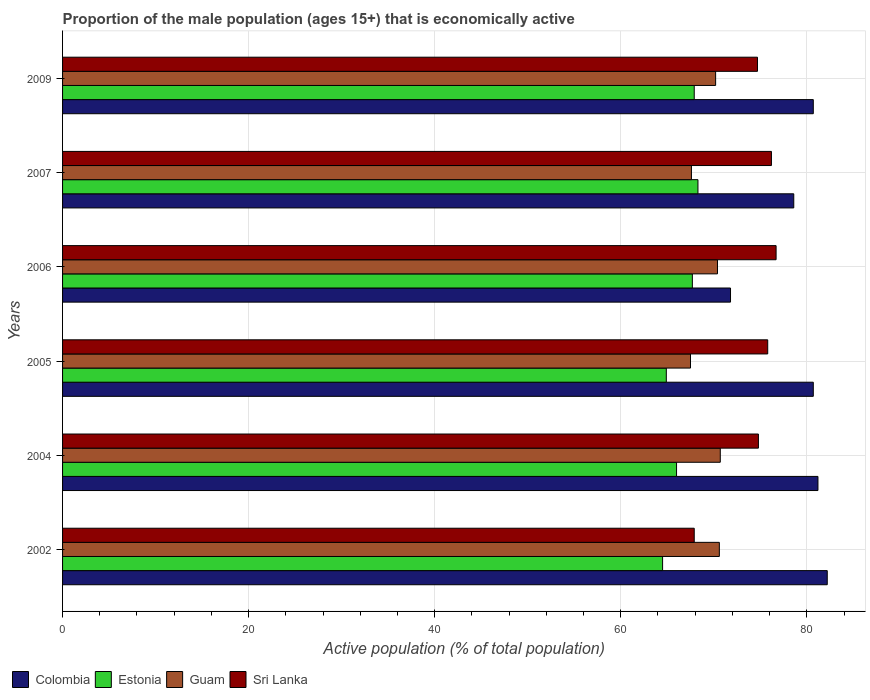Are the number of bars per tick equal to the number of legend labels?
Offer a terse response. Yes. Are the number of bars on each tick of the Y-axis equal?
Your response must be concise. Yes. What is the label of the 6th group of bars from the top?
Ensure brevity in your answer.  2002. What is the proportion of the male population that is economically active in Colombia in 2004?
Keep it short and to the point. 81.2. Across all years, what is the maximum proportion of the male population that is economically active in Colombia?
Keep it short and to the point. 82.2. Across all years, what is the minimum proportion of the male population that is economically active in Sri Lanka?
Your response must be concise. 67.9. In which year was the proportion of the male population that is economically active in Sri Lanka minimum?
Your answer should be compact. 2002. What is the total proportion of the male population that is economically active in Estonia in the graph?
Offer a terse response. 399.3. What is the difference between the proportion of the male population that is economically active in Guam in 2006 and that in 2009?
Provide a succinct answer. 0.2. What is the difference between the proportion of the male population that is economically active in Colombia in 2004 and the proportion of the male population that is economically active in Guam in 2009?
Your answer should be very brief. 11. What is the average proportion of the male population that is economically active in Colombia per year?
Make the answer very short. 79.2. In the year 2005, what is the difference between the proportion of the male population that is economically active in Sri Lanka and proportion of the male population that is economically active in Guam?
Keep it short and to the point. 8.3. What is the ratio of the proportion of the male population that is economically active in Guam in 2004 to that in 2007?
Your answer should be very brief. 1.05. Is the difference between the proportion of the male population that is economically active in Sri Lanka in 2002 and 2006 greater than the difference between the proportion of the male population that is economically active in Guam in 2002 and 2006?
Offer a terse response. No. What is the difference between the highest and the second highest proportion of the male population that is economically active in Guam?
Keep it short and to the point. 0.1. What is the difference between the highest and the lowest proportion of the male population that is economically active in Colombia?
Provide a short and direct response. 10.4. In how many years, is the proportion of the male population that is economically active in Guam greater than the average proportion of the male population that is economically active in Guam taken over all years?
Make the answer very short. 4. Is the sum of the proportion of the male population that is economically active in Estonia in 2005 and 2006 greater than the maximum proportion of the male population that is economically active in Colombia across all years?
Offer a very short reply. Yes. What does the 2nd bar from the top in 2006 represents?
Provide a succinct answer. Guam. What does the 3rd bar from the bottom in 2005 represents?
Your response must be concise. Guam. Are all the bars in the graph horizontal?
Make the answer very short. Yes. What is the difference between two consecutive major ticks on the X-axis?
Your response must be concise. 20. Does the graph contain grids?
Offer a terse response. Yes. Where does the legend appear in the graph?
Offer a terse response. Bottom left. How many legend labels are there?
Give a very brief answer. 4. What is the title of the graph?
Give a very brief answer. Proportion of the male population (ages 15+) that is economically active. Does "Portugal" appear as one of the legend labels in the graph?
Your answer should be compact. No. What is the label or title of the X-axis?
Make the answer very short. Active population (% of total population). What is the Active population (% of total population) of Colombia in 2002?
Keep it short and to the point. 82.2. What is the Active population (% of total population) of Estonia in 2002?
Your answer should be very brief. 64.5. What is the Active population (% of total population) in Guam in 2002?
Provide a short and direct response. 70.6. What is the Active population (% of total population) of Sri Lanka in 2002?
Offer a terse response. 67.9. What is the Active population (% of total population) in Colombia in 2004?
Ensure brevity in your answer.  81.2. What is the Active population (% of total population) of Estonia in 2004?
Your response must be concise. 66. What is the Active population (% of total population) in Guam in 2004?
Your answer should be compact. 70.7. What is the Active population (% of total population) of Sri Lanka in 2004?
Give a very brief answer. 74.8. What is the Active population (% of total population) in Colombia in 2005?
Make the answer very short. 80.7. What is the Active population (% of total population) of Estonia in 2005?
Ensure brevity in your answer.  64.9. What is the Active population (% of total population) of Guam in 2005?
Provide a succinct answer. 67.5. What is the Active population (% of total population) of Sri Lanka in 2005?
Ensure brevity in your answer.  75.8. What is the Active population (% of total population) in Colombia in 2006?
Ensure brevity in your answer.  71.8. What is the Active population (% of total population) of Estonia in 2006?
Give a very brief answer. 67.7. What is the Active population (% of total population) of Guam in 2006?
Your answer should be very brief. 70.4. What is the Active population (% of total population) in Sri Lanka in 2006?
Your answer should be very brief. 76.7. What is the Active population (% of total population) of Colombia in 2007?
Your answer should be very brief. 78.6. What is the Active population (% of total population) in Estonia in 2007?
Keep it short and to the point. 68.3. What is the Active population (% of total population) of Guam in 2007?
Make the answer very short. 67.6. What is the Active population (% of total population) of Sri Lanka in 2007?
Provide a short and direct response. 76.2. What is the Active population (% of total population) in Colombia in 2009?
Offer a very short reply. 80.7. What is the Active population (% of total population) of Estonia in 2009?
Ensure brevity in your answer.  67.9. What is the Active population (% of total population) of Guam in 2009?
Keep it short and to the point. 70.2. What is the Active population (% of total population) of Sri Lanka in 2009?
Your answer should be very brief. 74.7. Across all years, what is the maximum Active population (% of total population) of Colombia?
Your response must be concise. 82.2. Across all years, what is the maximum Active population (% of total population) of Estonia?
Offer a very short reply. 68.3. Across all years, what is the maximum Active population (% of total population) in Guam?
Provide a short and direct response. 70.7. Across all years, what is the maximum Active population (% of total population) of Sri Lanka?
Offer a terse response. 76.7. Across all years, what is the minimum Active population (% of total population) of Colombia?
Keep it short and to the point. 71.8. Across all years, what is the minimum Active population (% of total population) of Estonia?
Your answer should be compact. 64.5. Across all years, what is the minimum Active population (% of total population) of Guam?
Ensure brevity in your answer.  67.5. Across all years, what is the minimum Active population (% of total population) of Sri Lanka?
Your answer should be compact. 67.9. What is the total Active population (% of total population) in Colombia in the graph?
Provide a succinct answer. 475.2. What is the total Active population (% of total population) in Estonia in the graph?
Your answer should be compact. 399.3. What is the total Active population (% of total population) of Guam in the graph?
Provide a succinct answer. 417. What is the total Active population (% of total population) in Sri Lanka in the graph?
Offer a terse response. 446.1. What is the difference between the Active population (% of total population) of Guam in 2002 and that in 2004?
Your answer should be compact. -0.1. What is the difference between the Active population (% of total population) of Sri Lanka in 2002 and that in 2004?
Provide a succinct answer. -6.9. What is the difference between the Active population (% of total population) in Colombia in 2002 and that in 2005?
Your response must be concise. 1.5. What is the difference between the Active population (% of total population) in Estonia in 2002 and that in 2005?
Ensure brevity in your answer.  -0.4. What is the difference between the Active population (% of total population) of Colombia in 2002 and that in 2006?
Give a very brief answer. 10.4. What is the difference between the Active population (% of total population) of Estonia in 2002 and that in 2006?
Make the answer very short. -3.2. What is the difference between the Active population (% of total population) of Guam in 2002 and that in 2006?
Your answer should be very brief. 0.2. What is the difference between the Active population (% of total population) in Sri Lanka in 2002 and that in 2006?
Your answer should be very brief. -8.8. What is the difference between the Active population (% of total population) of Colombia in 2002 and that in 2007?
Provide a succinct answer. 3.6. What is the difference between the Active population (% of total population) in Guam in 2002 and that in 2007?
Ensure brevity in your answer.  3. What is the difference between the Active population (% of total population) in Sri Lanka in 2002 and that in 2007?
Your answer should be compact. -8.3. What is the difference between the Active population (% of total population) of Colombia in 2002 and that in 2009?
Keep it short and to the point. 1.5. What is the difference between the Active population (% of total population) in Guam in 2004 and that in 2005?
Ensure brevity in your answer.  3.2. What is the difference between the Active population (% of total population) in Sri Lanka in 2004 and that in 2005?
Provide a succinct answer. -1. What is the difference between the Active population (% of total population) of Colombia in 2004 and that in 2006?
Provide a succinct answer. 9.4. What is the difference between the Active population (% of total population) of Guam in 2004 and that in 2006?
Make the answer very short. 0.3. What is the difference between the Active population (% of total population) in Sri Lanka in 2004 and that in 2006?
Give a very brief answer. -1.9. What is the difference between the Active population (% of total population) in Colombia in 2004 and that in 2007?
Make the answer very short. 2.6. What is the difference between the Active population (% of total population) in Estonia in 2004 and that in 2007?
Your response must be concise. -2.3. What is the difference between the Active population (% of total population) of Guam in 2004 and that in 2007?
Your response must be concise. 3.1. What is the difference between the Active population (% of total population) in Colombia in 2004 and that in 2009?
Make the answer very short. 0.5. What is the difference between the Active population (% of total population) of Guam in 2004 and that in 2009?
Your response must be concise. 0.5. What is the difference between the Active population (% of total population) in Colombia in 2005 and that in 2006?
Make the answer very short. 8.9. What is the difference between the Active population (% of total population) of Estonia in 2005 and that in 2006?
Offer a terse response. -2.8. What is the difference between the Active population (% of total population) of Sri Lanka in 2005 and that in 2006?
Give a very brief answer. -0.9. What is the difference between the Active population (% of total population) in Colombia in 2005 and that in 2007?
Offer a very short reply. 2.1. What is the difference between the Active population (% of total population) in Sri Lanka in 2005 and that in 2009?
Provide a short and direct response. 1.1. What is the difference between the Active population (% of total population) of Colombia in 2006 and that in 2009?
Offer a terse response. -8.9. What is the difference between the Active population (% of total population) in Guam in 2006 and that in 2009?
Your response must be concise. 0.2. What is the difference between the Active population (% of total population) in Sri Lanka in 2006 and that in 2009?
Your response must be concise. 2. What is the difference between the Active population (% of total population) of Colombia in 2007 and that in 2009?
Make the answer very short. -2.1. What is the difference between the Active population (% of total population) of Colombia in 2002 and the Active population (% of total population) of Guam in 2004?
Provide a succinct answer. 11.5. What is the difference between the Active population (% of total population) in Colombia in 2002 and the Active population (% of total population) in Sri Lanka in 2004?
Give a very brief answer. 7.4. What is the difference between the Active population (% of total population) in Estonia in 2002 and the Active population (% of total population) in Guam in 2004?
Your answer should be very brief. -6.2. What is the difference between the Active population (% of total population) of Estonia in 2002 and the Active population (% of total population) of Sri Lanka in 2004?
Offer a very short reply. -10.3. What is the difference between the Active population (% of total population) of Guam in 2002 and the Active population (% of total population) of Sri Lanka in 2004?
Offer a very short reply. -4.2. What is the difference between the Active population (% of total population) of Estonia in 2002 and the Active population (% of total population) of Guam in 2005?
Offer a terse response. -3. What is the difference between the Active population (% of total population) of Guam in 2002 and the Active population (% of total population) of Sri Lanka in 2005?
Offer a very short reply. -5.2. What is the difference between the Active population (% of total population) in Colombia in 2002 and the Active population (% of total population) in Guam in 2006?
Your response must be concise. 11.8. What is the difference between the Active population (% of total population) of Estonia in 2002 and the Active population (% of total population) of Guam in 2006?
Offer a very short reply. -5.9. What is the difference between the Active population (% of total population) of Guam in 2002 and the Active population (% of total population) of Sri Lanka in 2006?
Your answer should be very brief. -6.1. What is the difference between the Active population (% of total population) in Colombia in 2002 and the Active population (% of total population) in Estonia in 2007?
Offer a very short reply. 13.9. What is the difference between the Active population (% of total population) in Colombia in 2002 and the Active population (% of total population) in Sri Lanka in 2007?
Keep it short and to the point. 6. What is the difference between the Active population (% of total population) of Estonia in 2002 and the Active population (% of total population) of Sri Lanka in 2007?
Give a very brief answer. -11.7. What is the difference between the Active population (% of total population) of Colombia in 2002 and the Active population (% of total population) of Estonia in 2009?
Your answer should be compact. 14.3. What is the difference between the Active population (% of total population) in Colombia in 2002 and the Active population (% of total population) in Guam in 2009?
Provide a succinct answer. 12. What is the difference between the Active population (% of total population) in Colombia in 2002 and the Active population (% of total population) in Sri Lanka in 2009?
Ensure brevity in your answer.  7.5. What is the difference between the Active population (% of total population) of Guam in 2002 and the Active population (% of total population) of Sri Lanka in 2009?
Your answer should be compact. -4.1. What is the difference between the Active population (% of total population) of Colombia in 2004 and the Active population (% of total population) of Guam in 2005?
Offer a very short reply. 13.7. What is the difference between the Active population (% of total population) of Estonia in 2004 and the Active population (% of total population) of Guam in 2005?
Make the answer very short. -1.5. What is the difference between the Active population (% of total population) of Colombia in 2004 and the Active population (% of total population) of Guam in 2006?
Your answer should be very brief. 10.8. What is the difference between the Active population (% of total population) in Estonia in 2004 and the Active population (% of total population) in Guam in 2006?
Offer a very short reply. -4.4. What is the difference between the Active population (% of total population) in Guam in 2004 and the Active population (% of total population) in Sri Lanka in 2006?
Your response must be concise. -6. What is the difference between the Active population (% of total population) in Colombia in 2004 and the Active population (% of total population) in Sri Lanka in 2007?
Offer a very short reply. 5. What is the difference between the Active population (% of total population) in Estonia in 2004 and the Active population (% of total population) in Sri Lanka in 2007?
Offer a very short reply. -10.2. What is the difference between the Active population (% of total population) of Colombia in 2004 and the Active population (% of total population) of Guam in 2009?
Your answer should be very brief. 11. What is the difference between the Active population (% of total population) in Estonia in 2004 and the Active population (% of total population) in Sri Lanka in 2009?
Provide a short and direct response. -8.7. What is the difference between the Active population (% of total population) in Colombia in 2005 and the Active population (% of total population) in Guam in 2006?
Keep it short and to the point. 10.3. What is the difference between the Active population (% of total population) of Estonia in 2005 and the Active population (% of total population) of Guam in 2006?
Ensure brevity in your answer.  -5.5. What is the difference between the Active population (% of total population) of Estonia in 2005 and the Active population (% of total population) of Sri Lanka in 2006?
Give a very brief answer. -11.8. What is the difference between the Active population (% of total population) in Colombia in 2005 and the Active population (% of total population) in Sri Lanka in 2007?
Make the answer very short. 4.5. What is the difference between the Active population (% of total population) of Estonia in 2005 and the Active population (% of total population) of Guam in 2007?
Offer a terse response. -2.7. What is the difference between the Active population (% of total population) in Colombia in 2005 and the Active population (% of total population) in Guam in 2009?
Offer a terse response. 10.5. What is the difference between the Active population (% of total population) in Estonia in 2005 and the Active population (% of total population) in Guam in 2009?
Your answer should be very brief. -5.3. What is the difference between the Active population (% of total population) of Guam in 2005 and the Active population (% of total population) of Sri Lanka in 2009?
Make the answer very short. -7.2. What is the difference between the Active population (% of total population) of Colombia in 2006 and the Active population (% of total population) of Guam in 2007?
Make the answer very short. 4.2. What is the difference between the Active population (% of total population) of Estonia in 2006 and the Active population (% of total population) of Guam in 2007?
Offer a terse response. 0.1. What is the difference between the Active population (% of total population) in Estonia in 2006 and the Active population (% of total population) in Sri Lanka in 2007?
Your response must be concise. -8.5. What is the difference between the Active population (% of total population) in Colombia in 2006 and the Active population (% of total population) in Guam in 2009?
Keep it short and to the point. 1.6. What is the difference between the Active population (% of total population) of Colombia in 2006 and the Active population (% of total population) of Sri Lanka in 2009?
Give a very brief answer. -2.9. What is the difference between the Active population (% of total population) of Estonia in 2006 and the Active population (% of total population) of Guam in 2009?
Keep it short and to the point. -2.5. What is the difference between the Active population (% of total population) of Estonia in 2006 and the Active population (% of total population) of Sri Lanka in 2009?
Your response must be concise. -7. What is the difference between the Active population (% of total population) in Colombia in 2007 and the Active population (% of total population) in Estonia in 2009?
Offer a terse response. 10.7. What is the difference between the Active population (% of total population) in Colombia in 2007 and the Active population (% of total population) in Guam in 2009?
Give a very brief answer. 8.4. What is the difference between the Active population (% of total population) of Estonia in 2007 and the Active population (% of total population) of Guam in 2009?
Offer a terse response. -1.9. What is the difference between the Active population (% of total population) of Estonia in 2007 and the Active population (% of total population) of Sri Lanka in 2009?
Give a very brief answer. -6.4. What is the average Active population (% of total population) of Colombia per year?
Keep it short and to the point. 79.2. What is the average Active population (% of total population) in Estonia per year?
Give a very brief answer. 66.55. What is the average Active population (% of total population) in Guam per year?
Your answer should be compact. 69.5. What is the average Active population (% of total population) of Sri Lanka per year?
Provide a succinct answer. 74.35. In the year 2002, what is the difference between the Active population (% of total population) in Colombia and Active population (% of total population) in Estonia?
Keep it short and to the point. 17.7. In the year 2002, what is the difference between the Active population (% of total population) of Colombia and Active population (% of total population) of Guam?
Your answer should be very brief. 11.6. In the year 2002, what is the difference between the Active population (% of total population) of Colombia and Active population (% of total population) of Sri Lanka?
Keep it short and to the point. 14.3. In the year 2002, what is the difference between the Active population (% of total population) of Estonia and Active population (% of total population) of Sri Lanka?
Your answer should be very brief. -3.4. In the year 2004, what is the difference between the Active population (% of total population) in Colombia and Active population (% of total population) in Estonia?
Provide a short and direct response. 15.2. In the year 2004, what is the difference between the Active population (% of total population) in Colombia and Active population (% of total population) in Guam?
Provide a succinct answer. 10.5. In the year 2004, what is the difference between the Active population (% of total population) of Guam and Active population (% of total population) of Sri Lanka?
Ensure brevity in your answer.  -4.1. In the year 2005, what is the difference between the Active population (% of total population) in Colombia and Active population (% of total population) in Estonia?
Ensure brevity in your answer.  15.8. In the year 2005, what is the difference between the Active population (% of total population) of Colombia and Active population (% of total population) of Guam?
Give a very brief answer. 13.2. In the year 2005, what is the difference between the Active population (% of total population) in Colombia and Active population (% of total population) in Sri Lanka?
Your response must be concise. 4.9. In the year 2005, what is the difference between the Active population (% of total population) of Estonia and Active population (% of total population) of Guam?
Give a very brief answer. -2.6. In the year 2005, what is the difference between the Active population (% of total population) in Estonia and Active population (% of total population) in Sri Lanka?
Provide a succinct answer. -10.9. In the year 2005, what is the difference between the Active population (% of total population) in Guam and Active population (% of total population) in Sri Lanka?
Your response must be concise. -8.3. In the year 2006, what is the difference between the Active population (% of total population) in Colombia and Active population (% of total population) in Guam?
Your response must be concise. 1.4. In the year 2006, what is the difference between the Active population (% of total population) in Colombia and Active population (% of total population) in Sri Lanka?
Offer a very short reply. -4.9. In the year 2007, what is the difference between the Active population (% of total population) in Colombia and Active population (% of total population) in Estonia?
Give a very brief answer. 10.3. In the year 2007, what is the difference between the Active population (% of total population) in Colombia and Active population (% of total population) in Guam?
Offer a terse response. 11. In the year 2007, what is the difference between the Active population (% of total population) of Colombia and Active population (% of total population) of Sri Lanka?
Ensure brevity in your answer.  2.4. In the year 2007, what is the difference between the Active population (% of total population) of Estonia and Active population (% of total population) of Guam?
Your response must be concise. 0.7. In the year 2007, what is the difference between the Active population (% of total population) in Estonia and Active population (% of total population) in Sri Lanka?
Ensure brevity in your answer.  -7.9. In the year 2009, what is the difference between the Active population (% of total population) of Colombia and Active population (% of total population) of Estonia?
Provide a short and direct response. 12.8. In the year 2009, what is the difference between the Active population (% of total population) in Estonia and Active population (% of total population) in Guam?
Your answer should be compact. -2.3. In the year 2009, what is the difference between the Active population (% of total population) of Estonia and Active population (% of total population) of Sri Lanka?
Offer a very short reply. -6.8. In the year 2009, what is the difference between the Active population (% of total population) in Guam and Active population (% of total population) in Sri Lanka?
Provide a succinct answer. -4.5. What is the ratio of the Active population (% of total population) in Colombia in 2002 to that in 2004?
Offer a very short reply. 1.01. What is the ratio of the Active population (% of total population) in Estonia in 2002 to that in 2004?
Give a very brief answer. 0.98. What is the ratio of the Active population (% of total population) in Sri Lanka in 2002 to that in 2004?
Make the answer very short. 0.91. What is the ratio of the Active population (% of total population) in Colombia in 2002 to that in 2005?
Keep it short and to the point. 1.02. What is the ratio of the Active population (% of total population) in Guam in 2002 to that in 2005?
Ensure brevity in your answer.  1.05. What is the ratio of the Active population (% of total population) of Sri Lanka in 2002 to that in 2005?
Provide a succinct answer. 0.9. What is the ratio of the Active population (% of total population) of Colombia in 2002 to that in 2006?
Ensure brevity in your answer.  1.14. What is the ratio of the Active population (% of total population) in Estonia in 2002 to that in 2006?
Your response must be concise. 0.95. What is the ratio of the Active population (% of total population) in Sri Lanka in 2002 to that in 2006?
Keep it short and to the point. 0.89. What is the ratio of the Active population (% of total population) of Colombia in 2002 to that in 2007?
Provide a short and direct response. 1.05. What is the ratio of the Active population (% of total population) of Guam in 2002 to that in 2007?
Offer a terse response. 1.04. What is the ratio of the Active population (% of total population) of Sri Lanka in 2002 to that in 2007?
Offer a terse response. 0.89. What is the ratio of the Active population (% of total population) in Colombia in 2002 to that in 2009?
Offer a very short reply. 1.02. What is the ratio of the Active population (% of total population) in Estonia in 2002 to that in 2009?
Provide a succinct answer. 0.95. What is the ratio of the Active population (% of total population) in Sri Lanka in 2002 to that in 2009?
Your answer should be very brief. 0.91. What is the ratio of the Active population (% of total population) in Estonia in 2004 to that in 2005?
Your response must be concise. 1.02. What is the ratio of the Active population (% of total population) of Guam in 2004 to that in 2005?
Your response must be concise. 1.05. What is the ratio of the Active population (% of total population) in Colombia in 2004 to that in 2006?
Give a very brief answer. 1.13. What is the ratio of the Active population (% of total population) of Estonia in 2004 to that in 2006?
Give a very brief answer. 0.97. What is the ratio of the Active population (% of total population) of Guam in 2004 to that in 2006?
Give a very brief answer. 1. What is the ratio of the Active population (% of total population) in Sri Lanka in 2004 to that in 2006?
Your answer should be compact. 0.98. What is the ratio of the Active population (% of total population) in Colombia in 2004 to that in 2007?
Offer a very short reply. 1.03. What is the ratio of the Active population (% of total population) in Estonia in 2004 to that in 2007?
Your answer should be compact. 0.97. What is the ratio of the Active population (% of total population) of Guam in 2004 to that in 2007?
Keep it short and to the point. 1.05. What is the ratio of the Active population (% of total population) of Sri Lanka in 2004 to that in 2007?
Keep it short and to the point. 0.98. What is the ratio of the Active population (% of total population) of Estonia in 2004 to that in 2009?
Make the answer very short. 0.97. What is the ratio of the Active population (% of total population) in Guam in 2004 to that in 2009?
Your response must be concise. 1.01. What is the ratio of the Active population (% of total population) in Colombia in 2005 to that in 2006?
Your answer should be very brief. 1.12. What is the ratio of the Active population (% of total population) in Estonia in 2005 to that in 2006?
Make the answer very short. 0.96. What is the ratio of the Active population (% of total population) of Guam in 2005 to that in 2006?
Your answer should be compact. 0.96. What is the ratio of the Active population (% of total population) of Sri Lanka in 2005 to that in 2006?
Your answer should be compact. 0.99. What is the ratio of the Active population (% of total population) of Colombia in 2005 to that in 2007?
Give a very brief answer. 1.03. What is the ratio of the Active population (% of total population) in Estonia in 2005 to that in 2007?
Offer a very short reply. 0.95. What is the ratio of the Active population (% of total population) in Guam in 2005 to that in 2007?
Provide a short and direct response. 1. What is the ratio of the Active population (% of total population) in Sri Lanka in 2005 to that in 2007?
Keep it short and to the point. 0.99. What is the ratio of the Active population (% of total population) in Estonia in 2005 to that in 2009?
Give a very brief answer. 0.96. What is the ratio of the Active population (% of total population) in Guam in 2005 to that in 2009?
Offer a terse response. 0.96. What is the ratio of the Active population (% of total population) of Sri Lanka in 2005 to that in 2009?
Offer a terse response. 1.01. What is the ratio of the Active population (% of total population) of Colombia in 2006 to that in 2007?
Keep it short and to the point. 0.91. What is the ratio of the Active population (% of total population) of Estonia in 2006 to that in 2007?
Keep it short and to the point. 0.99. What is the ratio of the Active population (% of total population) in Guam in 2006 to that in 2007?
Keep it short and to the point. 1.04. What is the ratio of the Active population (% of total population) of Sri Lanka in 2006 to that in 2007?
Ensure brevity in your answer.  1.01. What is the ratio of the Active population (% of total population) of Colombia in 2006 to that in 2009?
Offer a terse response. 0.89. What is the ratio of the Active population (% of total population) of Guam in 2006 to that in 2009?
Give a very brief answer. 1. What is the ratio of the Active population (% of total population) in Sri Lanka in 2006 to that in 2009?
Provide a succinct answer. 1.03. What is the ratio of the Active population (% of total population) in Colombia in 2007 to that in 2009?
Your answer should be very brief. 0.97. What is the ratio of the Active population (% of total population) of Estonia in 2007 to that in 2009?
Offer a very short reply. 1.01. What is the ratio of the Active population (% of total population) in Sri Lanka in 2007 to that in 2009?
Your response must be concise. 1.02. What is the difference between the highest and the second highest Active population (% of total population) in Colombia?
Keep it short and to the point. 1. What is the difference between the highest and the second highest Active population (% of total population) in Estonia?
Your answer should be very brief. 0.4. What is the difference between the highest and the lowest Active population (% of total population) in Estonia?
Your answer should be compact. 3.8. What is the difference between the highest and the lowest Active population (% of total population) in Guam?
Offer a very short reply. 3.2. 